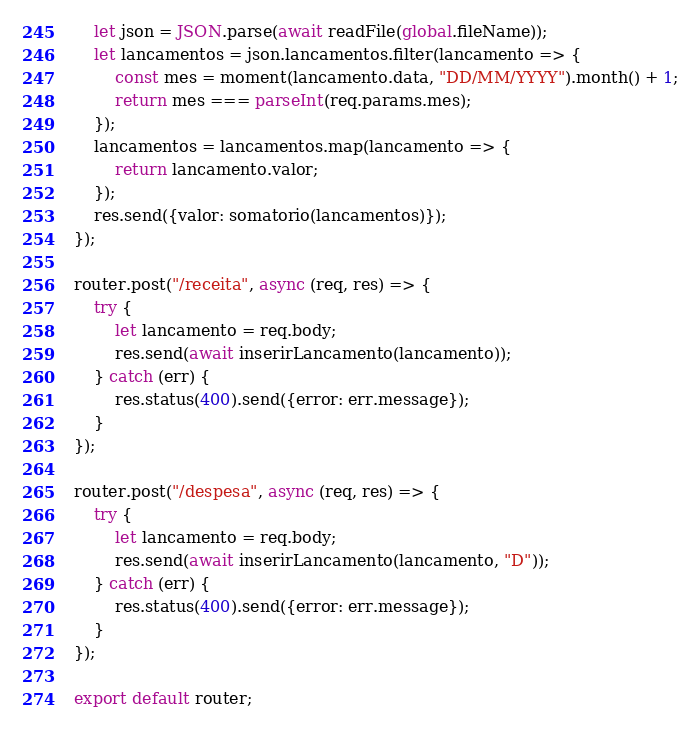<code> <loc_0><loc_0><loc_500><loc_500><_JavaScript_>    let json = JSON.parse(await readFile(global.fileName));
    let lancamentos = json.lancamentos.filter(lancamento => {
        const mes = moment(lancamento.data, "DD/MM/YYYY").month() + 1;
        return mes === parseInt(req.params.mes);        
    });
    lancamentos = lancamentos.map(lancamento => {
        return lancamento.valor;
    });
    res.send({valor: somatorio(lancamentos)});
});

router.post("/receita", async (req, res) => {
    try {
        let lancamento = req.body;        
        res.send(await inserirLancamento(lancamento));
    } catch (err) {
        res.status(400).send({error: err.message});
    }    
});

router.post("/despesa", async (req, res) => {
    try {
        let lancamento = req.body;
        res.send(await inserirLancamento(lancamento, "D"));
    } catch (err) {
        res.status(400).send({error: err.message});
    }    
});

export default router;</code> 